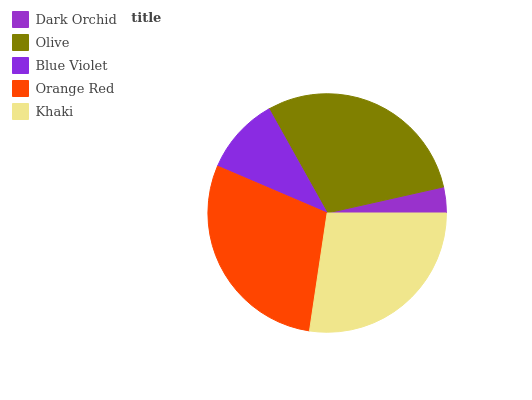Is Dark Orchid the minimum?
Answer yes or no. Yes. Is Olive the maximum?
Answer yes or no. Yes. Is Blue Violet the minimum?
Answer yes or no. No. Is Blue Violet the maximum?
Answer yes or no. No. Is Olive greater than Blue Violet?
Answer yes or no. Yes. Is Blue Violet less than Olive?
Answer yes or no. Yes. Is Blue Violet greater than Olive?
Answer yes or no. No. Is Olive less than Blue Violet?
Answer yes or no. No. Is Khaki the high median?
Answer yes or no. Yes. Is Khaki the low median?
Answer yes or no. Yes. Is Blue Violet the high median?
Answer yes or no. No. Is Dark Orchid the low median?
Answer yes or no. No. 